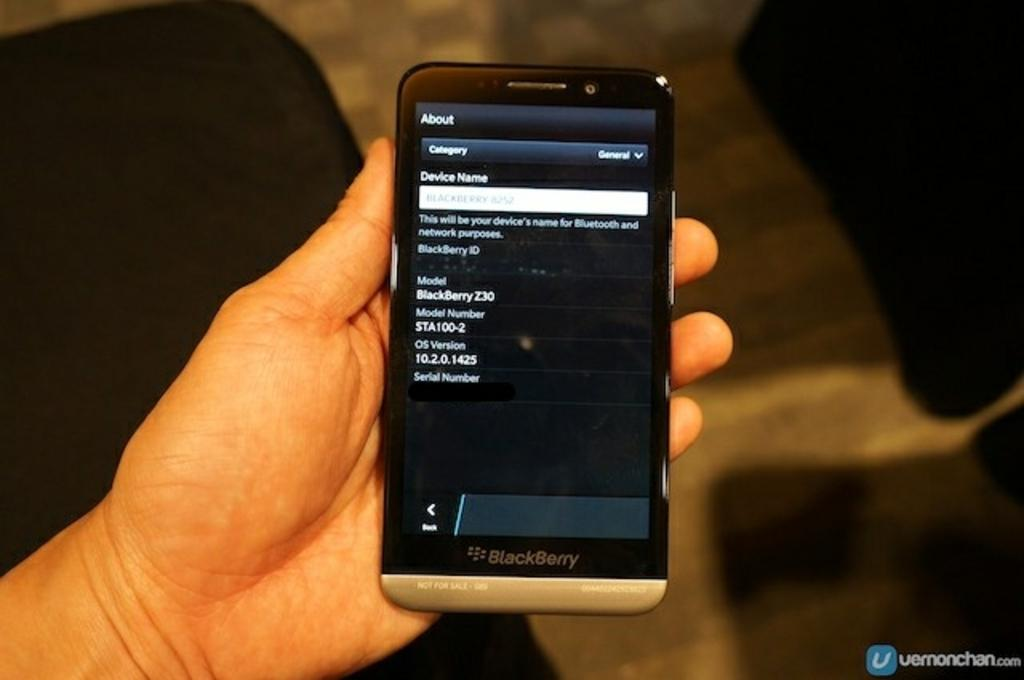<image>
Render a clear and concise summary of the photo. A hand is holding a turned on BlackBerry phone. 